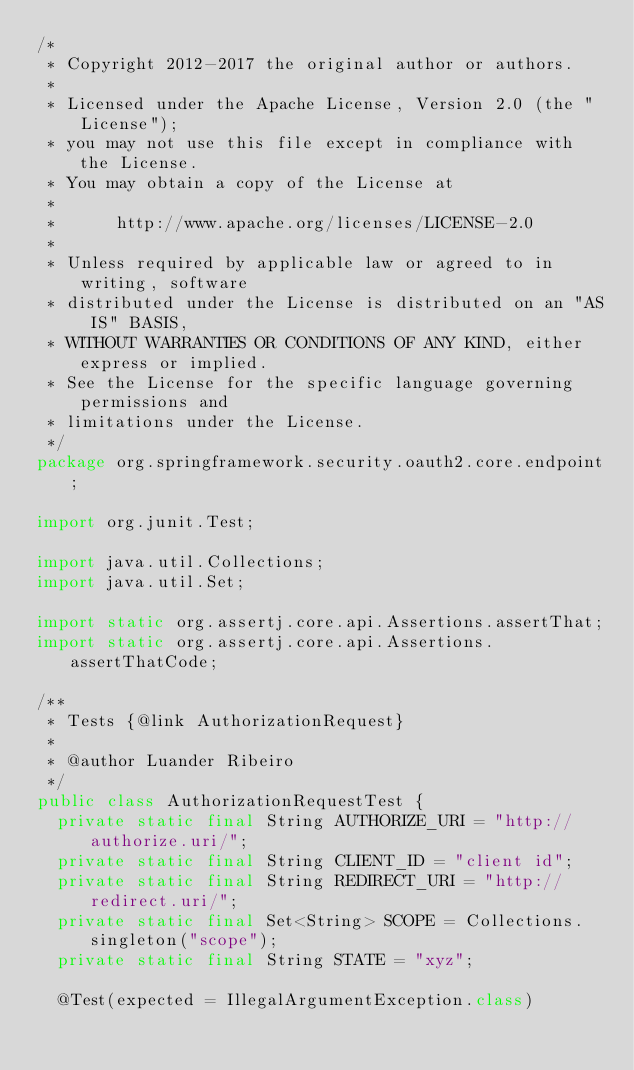<code> <loc_0><loc_0><loc_500><loc_500><_Java_>/*
 * Copyright 2012-2017 the original author or authors.
 *
 * Licensed under the Apache License, Version 2.0 (the "License");
 * you may not use this file except in compliance with the License.
 * You may obtain a copy of the License at
 *
 *      http://www.apache.org/licenses/LICENSE-2.0
 *
 * Unless required by applicable law or agreed to in writing, software
 * distributed under the License is distributed on an "AS IS" BASIS,
 * WITHOUT WARRANTIES OR CONDITIONS OF ANY KIND, either express or implied.
 * See the License for the specific language governing permissions and
 * limitations under the License.
 */
package org.springframework.security.oauth2.core.endpoint;

import org.junit.Test;

import java.util.Collections;
import java.util.Set;

import static org.assertj.core.api.Assertions.assertThat;
import static org.assertj.core.api.Assertions.assertThatCode;

/**
 * Tests {@link AuthorizationRequest}
 *
 * @author Luander Ribeiro
 */
public class AuthorizationRequestTest {
	private static final String AUTHORIZE_URI = "http://authorize.uri/";
	private static final String CLIENT_ID = "client id";
	private static final String REDIRECT_URI = "http://redirect.uri/";
	private static final Set<String> SCOPE = Collections.singleton("scope");
	private static final String STATE = "xyz";

	@Test(expected = IllegalArgumentException.class)</code> 